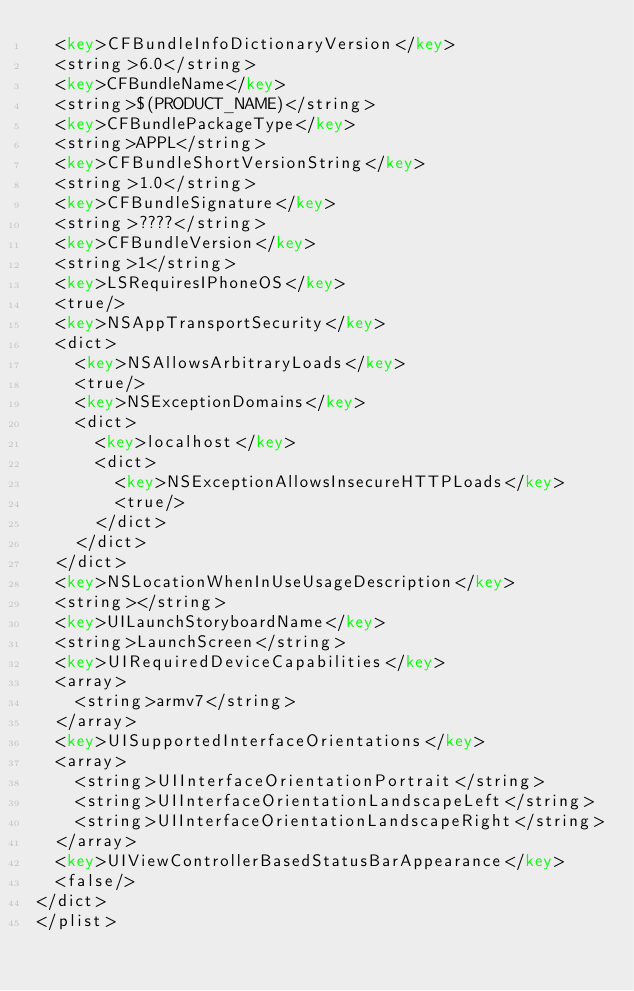<code> <loc_0><loc_0><loc_500><loc_500><_XML_>	<key>CFBundleInfoDictionaryVersion</key>
	<string>6.0</string>
	<key>CFBundleName</key>
	<string>$(PRODUCT_NAME)</string>
	<key>CFBundlePackageType</key>
	<string>APPL</string>
	<key>CFBundleShortVersionString</key>
	<string>1.0</string>
	<key>CFBundleSignature</key>
	<string>????</string>
	<key>CFBundleVersion</key>
	<string>1</string>
	<key>LSRequiresIPhoneOS</key>
	<true/>
	<key>NSAppTransportSecurity</key>
	<dict>
		<key>NSAllowsArbitraryLoads</key>
		<true/>
		<key>NSExceptionDomains</key>
		<dict>
			<key>localhost</key>
			<dict>
				<key>NSExceptionAllowsInsecureHTTPLoads</key>
				<true/>
			</dict>
		</dict>
	</dict>
	<key>NSLocationWhenInUseUsageDescription</key>
	<string></string>
	<key>UILaunchStoryboardName</key>
	<string>LaunchScreen</string>
	<key>UIRequiredDeviceCapabilities</key>
	<array>
		<string>armv7</string>
	</array>
	<key>UISupportedInterfaceOrientations</key>
	<array>
		<string>UIInterfaceOrientationPortrait</string>
		<string>UIInterfaceOrientationLandscapeLeft</string>
		<string>UIInterfaceOrientationLandscapeRight</string>
	</array>
	<key>UIViewControllerBasedStatusBarAppearance</key>
	<false/>
</dict>
</plist>
</code> 